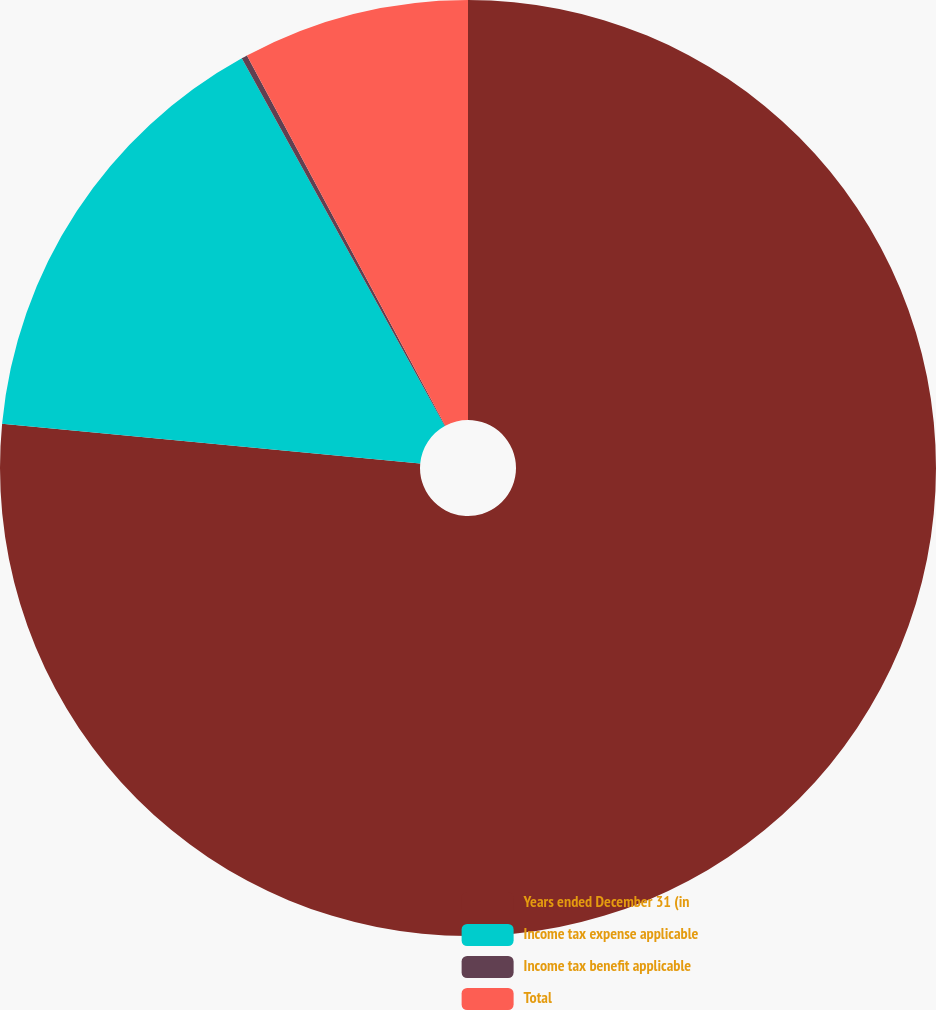<chart> <loc_0><loc_0><loc_500><loc_500><pie_chart><fcel>Years ended December 31 (in<fcel>Income tax expense applicable<fcel>Income tax benefit applicable<fcel>Total<nl><fcel>76.51%<fcel>15.46%<fcel>0.2%<fcel>7.83%<nl></chart> 